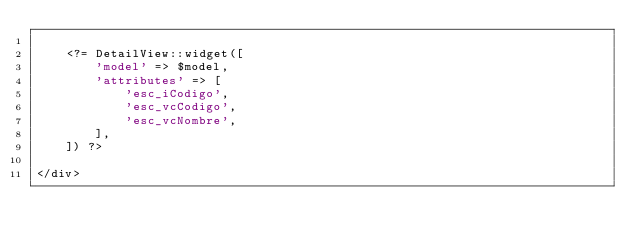<code> <loc_0><loc_0><loc_500><loc_500><_PHP_>
    <?= DetailView::widget([
        'model' => $model,
        'attributes' => [
            'esc_iCodigo',
            'esc_vcCodigo',
            'esc_vcNombre',
        ],
    ]) ?>

</div>
</code> 